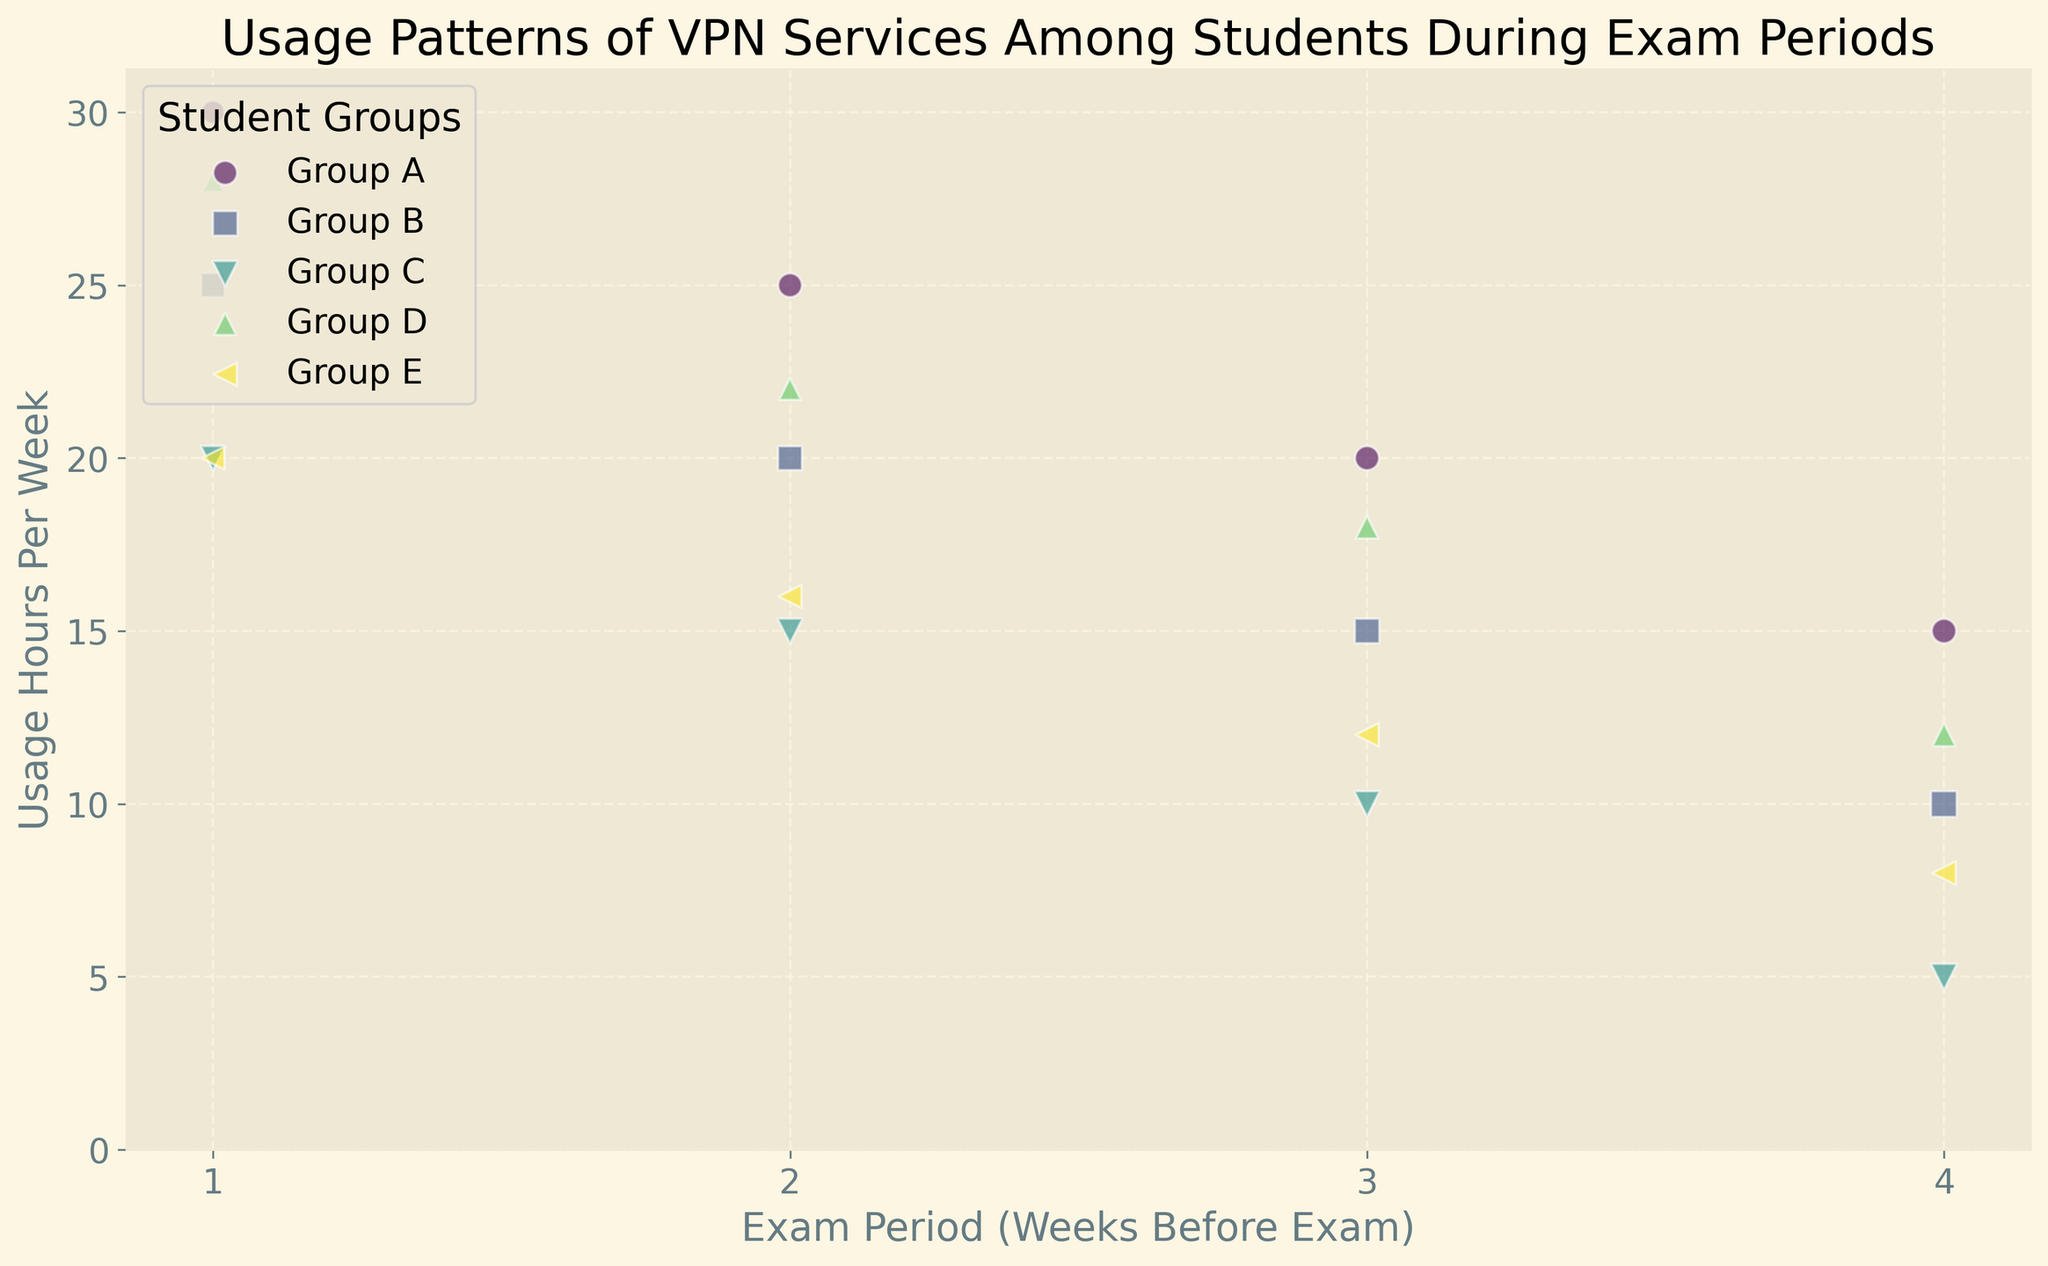What's the trend in VPN usage hours per week for Group A as the exam period approaches? VPN usage hours per week for Group A increase as the exam period approaches from 15 hours (4 weeks before) to 30 hours (1 week before).
Answer: Increases Which group had the highest VPN usage in the last week before exams? In the last week before exams (1 week before), Group A had the highest VPN usage of 30 hours per week.
Answer: Group A How does the number of students in Group C change as the exam period gets closer? For Group C, the number of students decreases from 230 (4 weeks before) to 200 (1 week before).
Answer: Decreases Which group shows the most significant increase in VPN usage hours per week as the exam period approaches, from four weeks before to one week before the exam? Comparing the VPN usage hours increase from 4 weeks to 1 week before the exam, Group A has the most significant increase from 15 to 30 hours per week.
Answer: Group A Compare the VPN usage hours per week between Group B and Group D three weeks before the exams. Three weeks before the exams, Group B used VPN for 15 hours per week while Group D used it for 18 hours per week.
Answer: Group D How do the bubble sizes corresponding to Group B and Group E compare at four weeks before the exams? At four weeks before the exams, the bubble sizes for Group B and Group E correspond to 220 and 190 students, respectively. Group B has a larger bubble size.
Answer: Group B Which group had the smallest number of students one week before the exams? One week before the exams, Group D had the smallest number of students, with 150 students.
Answer: Group D Which student group had the maximum VPN usage hours per week four weeks before the exam period? Four weeks before the exam period, Group A had the maximum VPN usage hours per week with 15 hours.
Answer: Group A If we sum the number of students in Group A and Group B in the last week before exams, what is the total? In the last week before exams, Group A has 180 students and Group B has 190 students. The sum is 180 + 190 = 370 students.
Answer: 370 